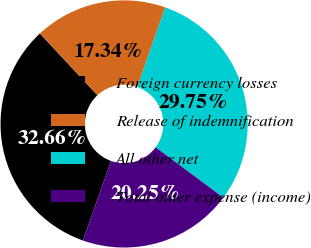<chart> <loc_0><loc_0><loc_500><loc_500><pie_chart><fcel>Foreign currency losses<fcel>Release of indemnification<fcel>All other net<fcel>Total other expense (income)<nl><fcel>32.66%<fcel>17.34%<fcel>29.75%<fcel>20.25%<nl></chart> 